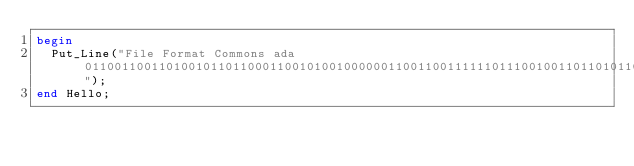Convert code to text. <code><loc_0><loc_0><loc_500><loc_500><_Ada_>begin
  Put_Line("File Format Commons ada 0110011001101001011011000110010100100000011001100111111011100100110110101100001011101000010000001100011011011110110110101101101011011110110111001110011");
end Hello;
</code> 